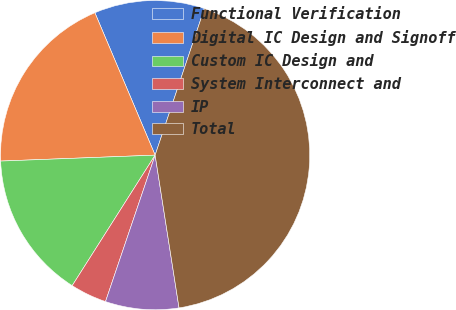Convert chart to OTSL. <chart><loc_0><loc_0><loc_500><loc_500><pie_chart><fcel>Functional Verification<fcel>Digital IC Design and Signoff<fcel>Custom IC Design and<fcel>System Interconnect and<fcel>IP<fcel>Total<nl><fcel>11.53%<fcel>19.24%<fcel>15.38%<fcel>3.81%<fcel>7.67%<fcel>42.37%<nl></chart> 